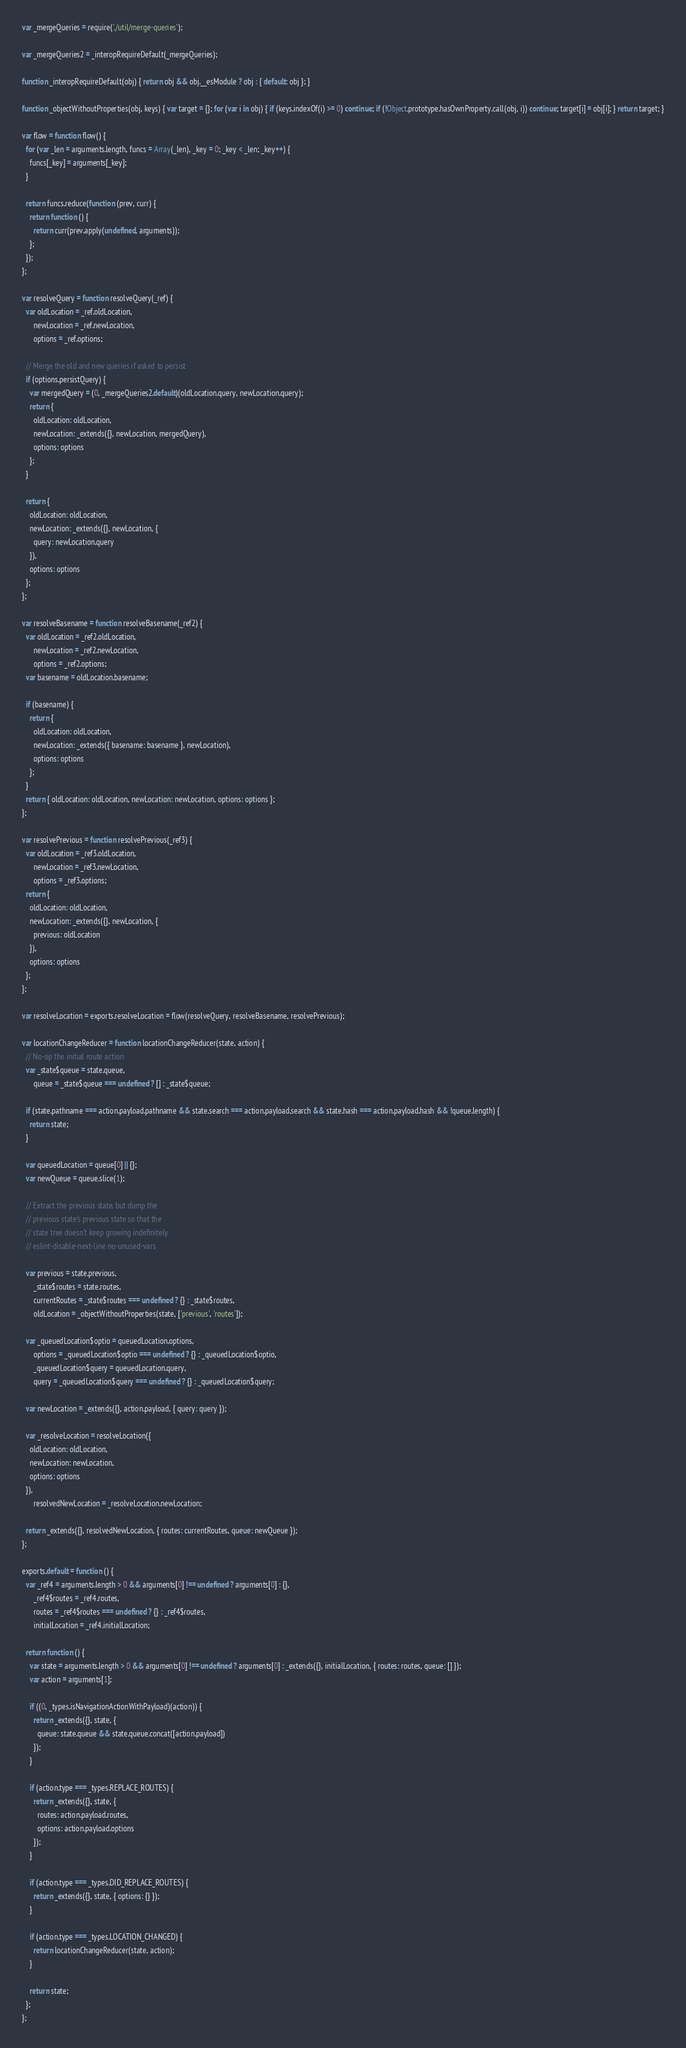Convert code to text. <code><loc_0><loc_0><loc_500><loc_500><_JavaScript_>
var _mergeQueries = require('./util/merge-queries');

var _mergeQueries2 = _interopRequireDefault(_mergeQueries);

function _interopRequireDefault(obj) { return obj && obj.__esModule ? obj : { default: obj }; }

function _objectWithoutProperties(obj, keys) { var target = {}; for (var i in obj) { if (keys.indexOf(i) >= 0) continue; if (!Object.prototype.hasOwnProperty.call(obj, i)) continue; target[i] = obj[i]; } return target; }

var flow = function flow() {
  for (var _len = arguments.length, funcs = Array(_len), _key = 0; _key < _len; _key++) {
    funcs[_key] = arguments[_key];
  }

  return funcs.reduce(function (prev, curr) {
    return function () {
      return curr(prev.apply(undefined, arguments));
    };
  });
};

var resolveQuery = function resolveQuery(_ref) {
  var oldLocation = _ref.oldLocation,
      newLocation = _ref.newLocation,
      options = _ref.options;

  // Merge the old and new queries if asked to persist
  if (options.persistQuery) {
    var mergedQuery = (0, _mergeQueries2.default)(oldLocation.query, newLocation.query);
    return {
      oldLocation: oldLocation,
      newLocation: _extends({}, newLocation, mergedQuery),
      options: options
    };
  }

  return {
    oldLocation: oldLocation,
    newLocation: _extends({}, newLocation, {
      query: newLocation.query
    }),
    options: options
  };
};

var resolveBasename = function resolveBasename(_ref2) {
  var oldLocation = _ref2.oldLocation,
      newLocation = _ref2.newLocation,
      options = _ref2.options;
  var basename = oldLocation.basename;

  if (basename) {
    return {
      oldLocation: oldLocation,
      newLocation: _extends({ basename: basename }, newLocation),
      options: options
    };
  }
  return { oldLocation: oldLocation, newLocation: newLocation, options: options };
};

var resolvePrevious = function resolvePrevious(_ref3) {
  var oldLocation = _ref3.oldLocation,
      newLocation = _ref3.newLocation,
      options = _ref3.options;
  return {
    oldLocation: oldLocation,
    newLocation: _extends({}, newLocation, {
      previous: oldLocation
    }),
    options: options
  };
};

var resolveLocation = exports.resolveLocation = flow(resolveQuery, resolveBasename, resolvePrevious);

var locationChangeReducer = function locationChangeReducer(state, action) {
  // No-op the initial route action
  var _state$queue = state.queue,
      queue = _state$queue === undefined ? [] : _state$queue;

  if (state.pathname === action.payload.pathname && state.search === action.payload.search && state.hash === action.payload.hash && !queue.length) {
    return state;
  }

  var queuedLocation = queue[0] || {};
  var newQueue = queue.slice(1);

  // Extract the previous state, but dump the
  // previous state's previous state so that the
  // state tree doesn't keep growing indefinitely
  // eslint-disable-next-line no-unused-vars

  var previous = state.previous,
      _state$routes = state.routes,
      currentRoutes = _state$routes === undefined ? {} : _state$routes,
      oldLocation = _objectWithoutProperties(state, ['previous', 'routes']);

  var _queuedLocation$optio = queuedLocation.options,
      options = _queuedLocation$optio === undefined ? {} : _queuedLocation$optio,
      _queuedLocation$query = queuedLocation.query,
      query = _queuedLocation$query === undefined ? {} : _queuedLocation$query;

  var newLocation = _extends({}, action.payload, { query: query });

  var _resolveLocation = resolveLocation({
    oldLocation: oldLocation,
    newLocation: newLocation,
    options: options
  }),
      resolvedNewLocation = _resolveLocation.newLocation;

  return _extends({}, resolvedNewLocation, { routes: currentRoutes, queue: newQueue });
};

exports.default = function () {
  var _ref4 = arguments.length > 0 && arguments[0] !== undefined ? arguments[0] : {},
      _ref4$routes = _ref4.routes,
      routes = _ref4$routes === undefined ? {} : _ref4$routes,
      initialLocation = _ref4.initialLocation;

  return function () {
    var state = arguments.length > 0 && arguments[0] !== undefined ? arguments[0] : _extends({}, initialLocation, { routes: routes, queue: [] });
    var action = arguments[1];

    if ((0, _types.isNavigationActionWithPayload)(action)) {
      return _extends({}, state, {
        queue: state.queue && state.queue.concat([action.payload])
      });
    }

    if (action.type === _types.REPLACE_ROUTES) {
      return _extends({}, state, {
        routes: action.payload.routes,
        options: action.payload.options
      });
    }

    if (action.type === _types.DID_REPLACE_ROUTES) {
      return _extends({}, state, { options: {} });
    }

    if (action.type === _types.LOCATION_CHANGED) {
      return locationChangeReducer(state, action);
    }

    return state;
  };
};</code> 